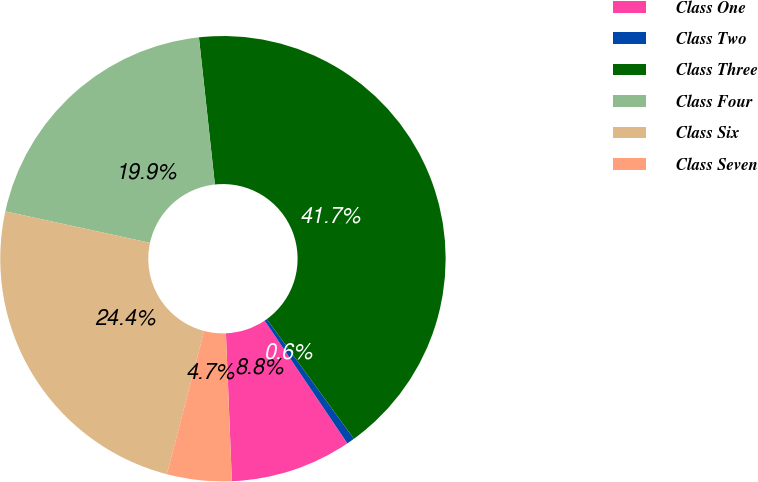<chart> <loc_0><loc_0><loc_500><loc_500><pie_chart><fcel>Class One<fcel>Class Two<fcel>Class Three<fcel>Class Four<fcel>Class Six<fcel>Class Seven<nl><fcel>8.8%<fcel>0.57%<fcel>41.71%<fcel>19.87%<fcel>24.36%<fcel>4.69%<nl></chart> 